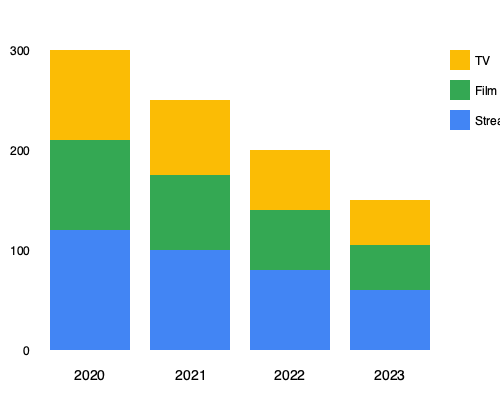Based on the stacked bar chart showing detective story adaptations across different media formats from 2020 to 2023, which format has consistently shown the highest number of adaptations each year? To determine which format has consistently shown the highest number of adaptations each year, we need to analyze the chart year by year:

1. 2020 (leftmost bar):
   - TV (yellow): 90 adaptations
   - Film (green): 90 adaptations
   - Streaming (blue): 120 adaptations

2. 2021 (second bar from left):
   - TV (yellow): 75 adaptations
   - Film (green): 75 adaptations
   - Streaming (blue): 100 adaptations

3. 2022 (third bar from left):
   - TV (yellow): 60 adaptations
   - Film (green): 60 adaptations
   - Streaming (blue): 80 adaptations

4. 2023 (rightmost bar):
   - TV (yellow): 45 adaptations
   - Film (green): 45 adaptations
   - Streaming (blue): 60 adaptations

In each year, the blue section (representing streaming) is consistently the largest, indicating that streaming platforms have had the highest number of detective story adaptations every year from 2020 to 2023.
Answer: Streaming 